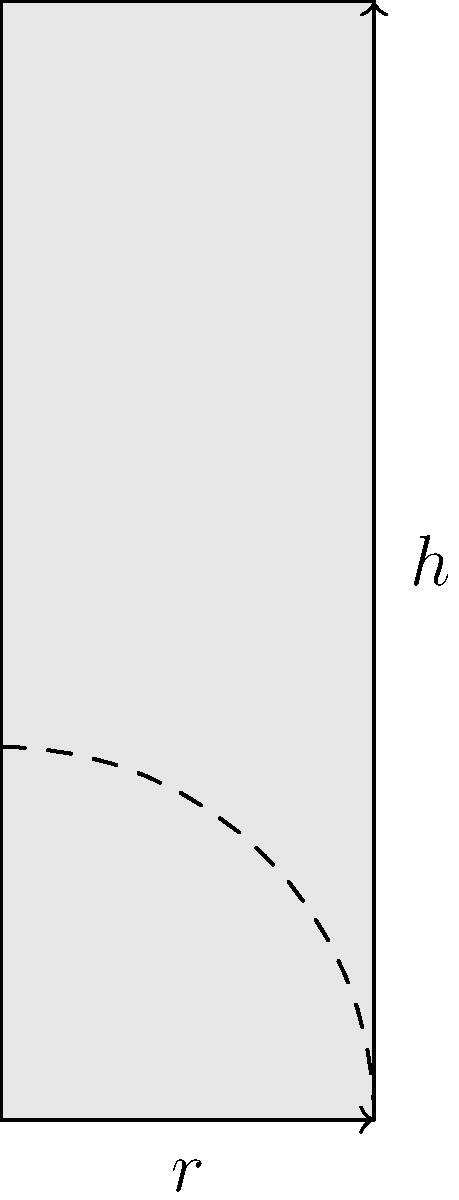As a news reporter covering climate change and disaster relief efforts, you're investigating the efficiency of emergency supply distribution. Cylindrical containers are being used to pack and transport essential items. If the radius of the base is $r$ and the height is $h$, what is the optimal ratio of $h$ to $r$ that maximizes the volume while minimizing the surface area? This ratio is crucial for designing containers that are both space-efficient and cost-effective in terms of materials used. To find the optimal ratio of height to radius, we need to follow these steps:

1) The volume of a cylinder is given by $V = \pi r^2 h$

2) The surface area of a cylinder (including top and bottom) is $S = 2\pi r^2 + 2\pi r h$

3) We want to maximize volume while minimizing surface area. This is equivalent to maximizing the ratio $\frac{V}{S}$

4) Let's express this ratio in terms of $r$ and $h$:

   $$\frac{V}{S} = \frac{\pi r^2 h}{2\pi r^2 + 2\pi r h} = \frac{r h}{2r + 2h}$$

5) Now, let $h = k r$, where $k$ is the ratio we're looking for. Substituting:

   $$\frac{V}{S} = \frac{r (k r)}{2r + 2(k r)} = \frac{k r^2}{2r(1 + k)} = \frac{k r}{2(1 + k)}$$

6) To maximize this, we differentiate with respect to $k$ and set it to zero:

   $$\frac{d}{dk}(\frac{k r}{2(1 + k)}) = \frac{r(2(1+k)) - 2r k}{4(1+k)^2} = \frac{r(2-k)}{2(1+k)^2} = 0$$

7) Solving this equation:

   $r(2-k) = 0$
   $k = 2$

8) This means the optimal ratio of height to radius is 2:1.

This ratio ensures the most efficient use of materials (minimizing surface area) while maximizing the volume of supplies that can be transported, which is crucial for effective emergency response in climate-related disasters.
Answer: 2:1 